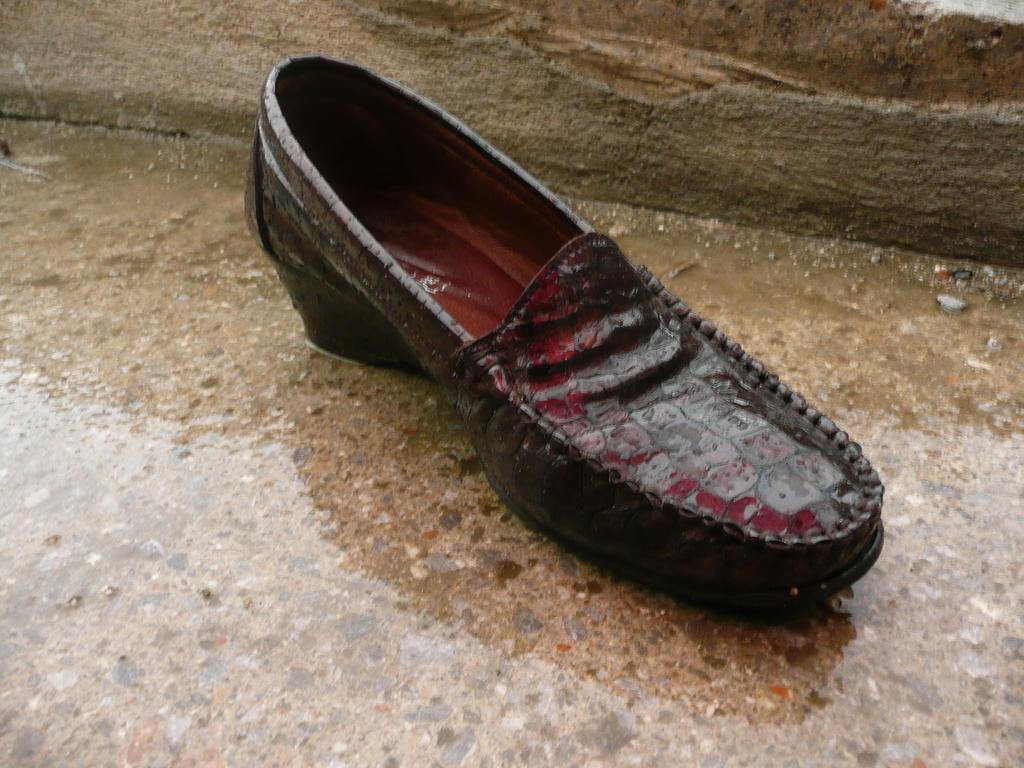How would you summarize this image in a sentence or two? In this picture there is a wet shoe which is placed on a wet ground. 